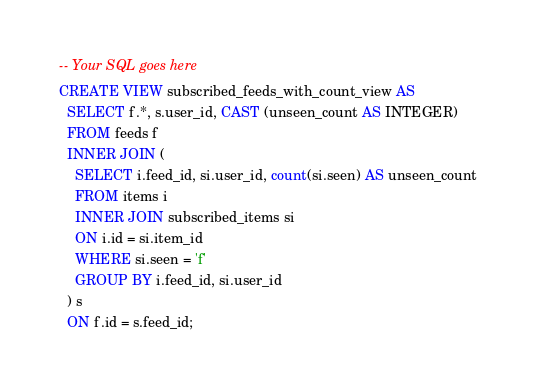<code> <loc_0><loc_0><loc_500><loc_500><_SQL_>-- Your SQL goes here
CREATE VIEW subscribed_feeds_with_count_view AS
  SELECT f.*, s.user_id, CAST (unseen_count AS INTEGER)
  FROM feeds f
  INNER JOIN (
    SELECT i.feed_id, si.user_id, count(si.seen) AS unseen_count
    FROM items i
    INNER JOIN subscribed_items si
    ON i.id = si.item_id
    WHERE si.seen = 'f'
    GROUP BY i.feed_id, si.user_id
  ) s
  ON f.id = s.feed_id;
</code> 